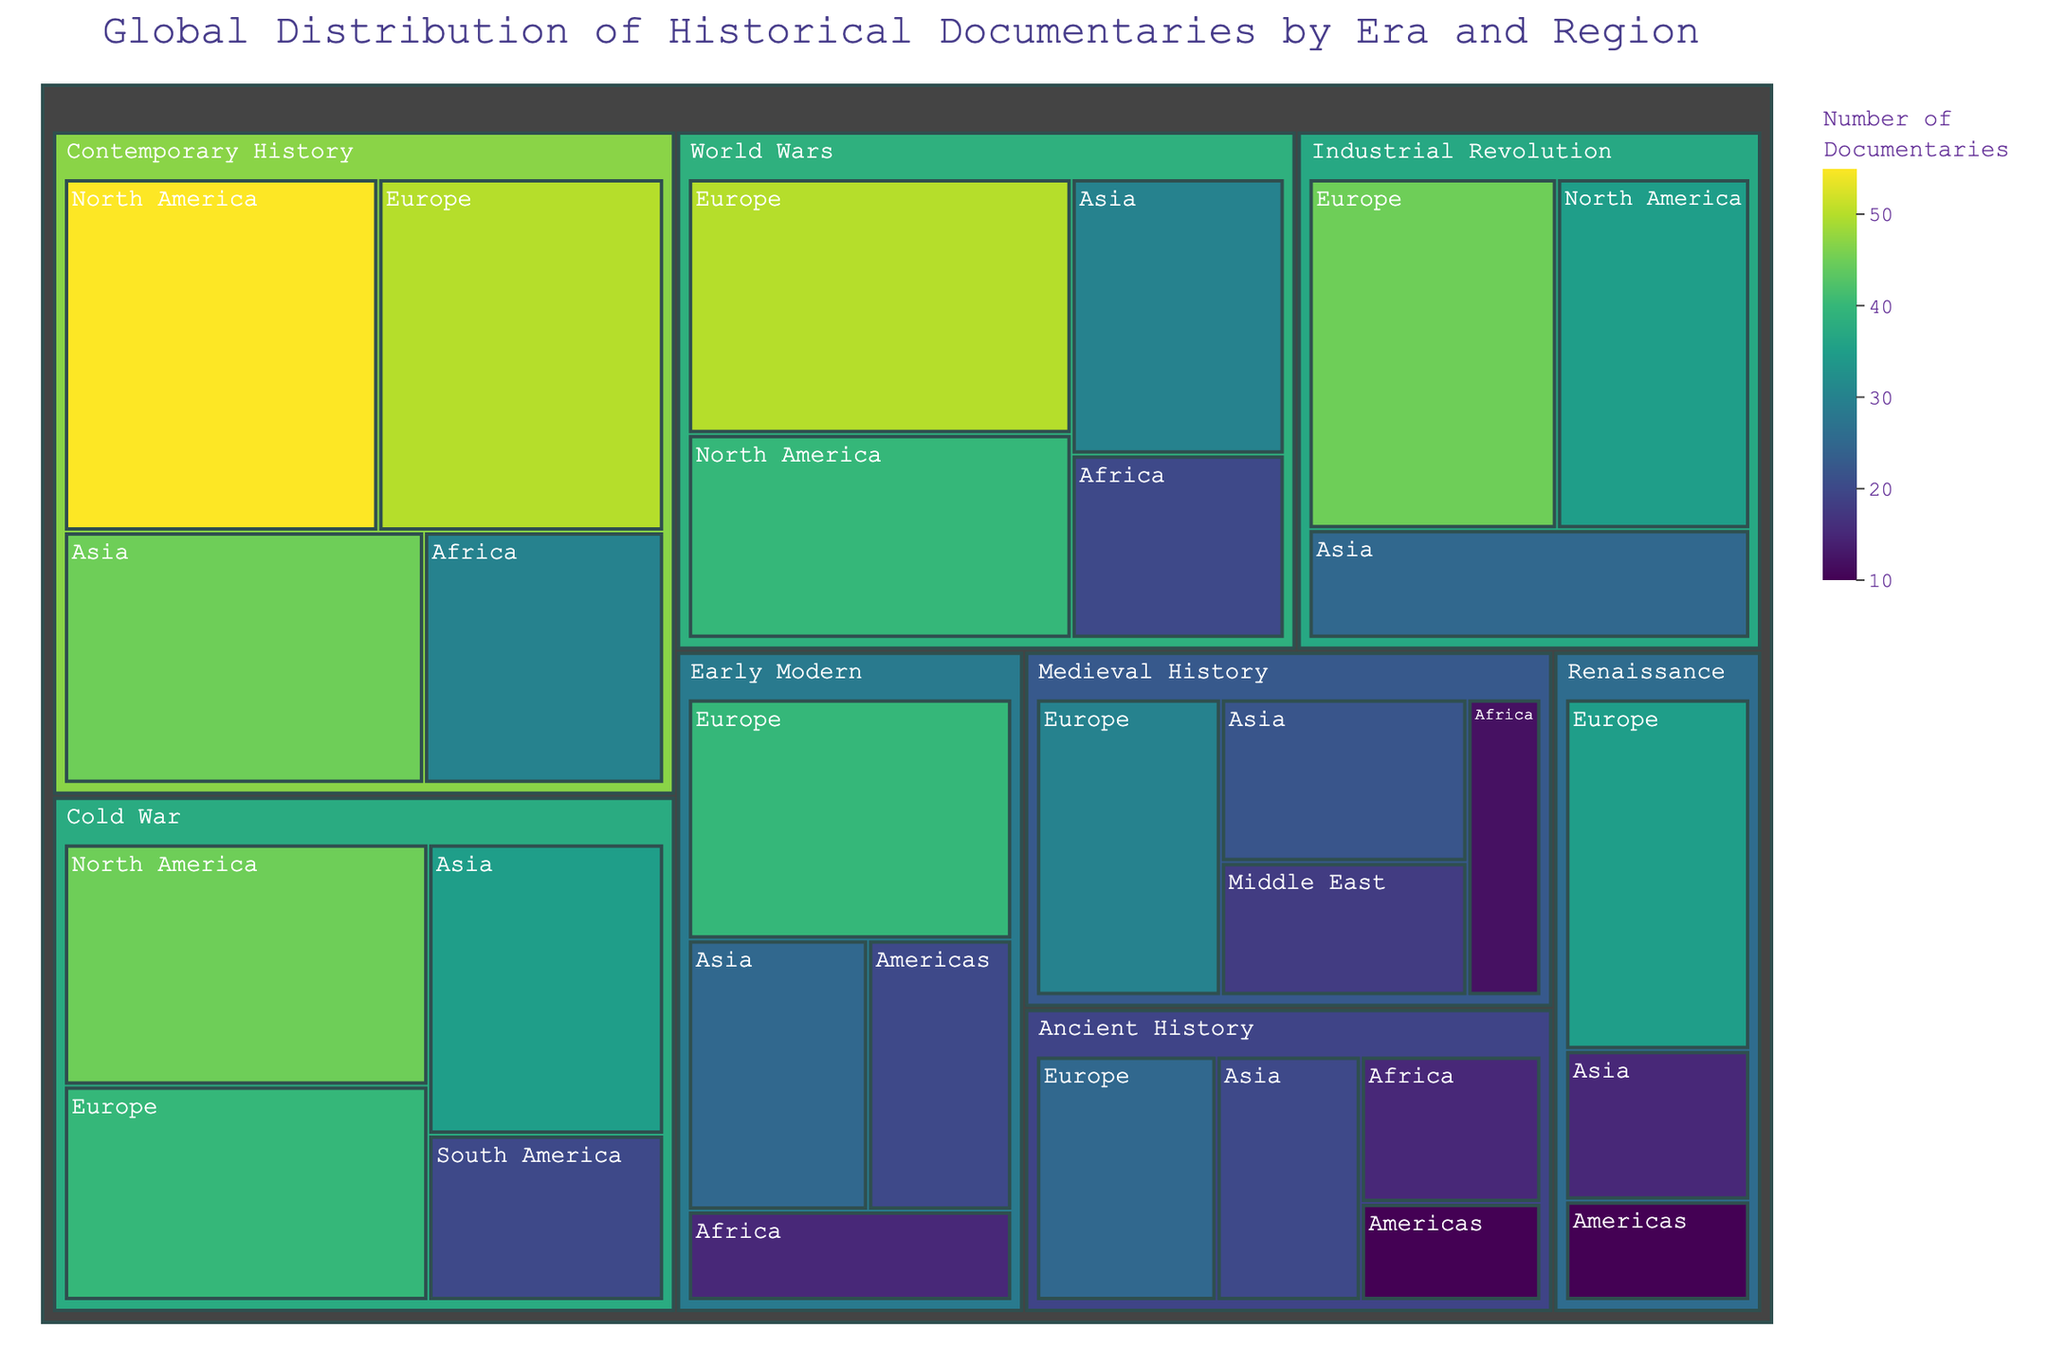What is the title of the treemap? The title of the treemap is usually displayed prominently at the top, summarizing what the visualization is about.
Answer: Global Distribution of Historical Documentaries by Era and Region Which era has the highest number of documentaries? By identifying the largest area on the treemap, we can determine which era has the highest number of documentaries.
Answer: Contemporary History How many documentaries in total are there for the Industrial Revolution? Adding all the values within the Industrial Revolution section gives the total. Europe (45) + North America (35) + Asia (25) equals 105.
Answer: 105 Which region in the Early Modern era has the fewest documentaries? By comparing the sizes of regions within the Early Modern category, the smallest area corresponds to the fewest documentaries.
Answer: Africa Compare the number of documentaries between Medieval History in Europe and Asia. Which has more? Evaluating the size and value for Europe (30) and Asia (22) within the Medieval era reveals Europe has more documentaries than Asia.
Answer: Europe Does the Cold War have more documentaries in Europe or North America? By comparing the numerical values between Europe (40) and North America (45) under the Cold War category, North America has more documentaries.
Answer: North America Summarize the number of documentaries for the Asia region by adding all values across different eras. Adding values from Asia across all eras involves: 20 (Ancient History) + 22 (Medieval History) + 15 (Renaissance) + 25 (Early Modern) + 25 (Industrial Revolution) + 30 (World Wars) + 35 (Cold War) + 45 (Contemporary History) = 217.
Answer: 217 Which era has the smallest number of documentaries for Africa? By comparing the values within Africa across different eras: Ancient History (15), Medieval History (12), Early Modern (15), World Wars (20), Contemporary History (30), Medieval History has the fewest with 12.
Answer: Medieval History What is the total number of documentaries in the Cold War era? Summing all documentaries from regions under the Cold War era: North America (45) + Europe (40) + Asia (35) + South America (20) equals 140.
Answer: 140 Which two eras have the closest number of documentaries in Europe? Comparing the values for Europe across different eras identifies which are closest in value: Renaissance (35) and Early Modern (40) are close with a difference of 5.
Answer: Renaissance and Early Modern 